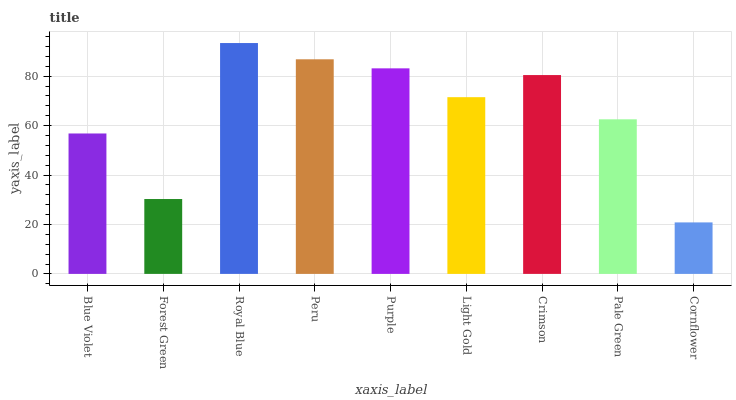Is Cornflower the minimum?
Answer yes or no. Yes. Is Royal Blue the maximum?
Answer yes or no. Yes. Is Forest Green the minimum?
Answer yes or no. No. Is Forest Green the maximum?
Answer yes or no. No. Is Blue Violet greater than Forest Green?
Answer yes or no. Yes. Is Forest Green less than Blue Violet?
Answer yes or no. Yes. Is Forest Green greater than Blue Violet?
Answer yes or no. No. Is Blue Violet less than Forest Green?
Answer yes or no. No. Is Light Gold the high median?
Answer yes or no. Yes. Is Light Gold the low median?
Answer yes or no. Yes. Is Blue Violet the high median?
Answer yes or no. No. Is Royal Blue the low median?
Answer yes or no. No. 